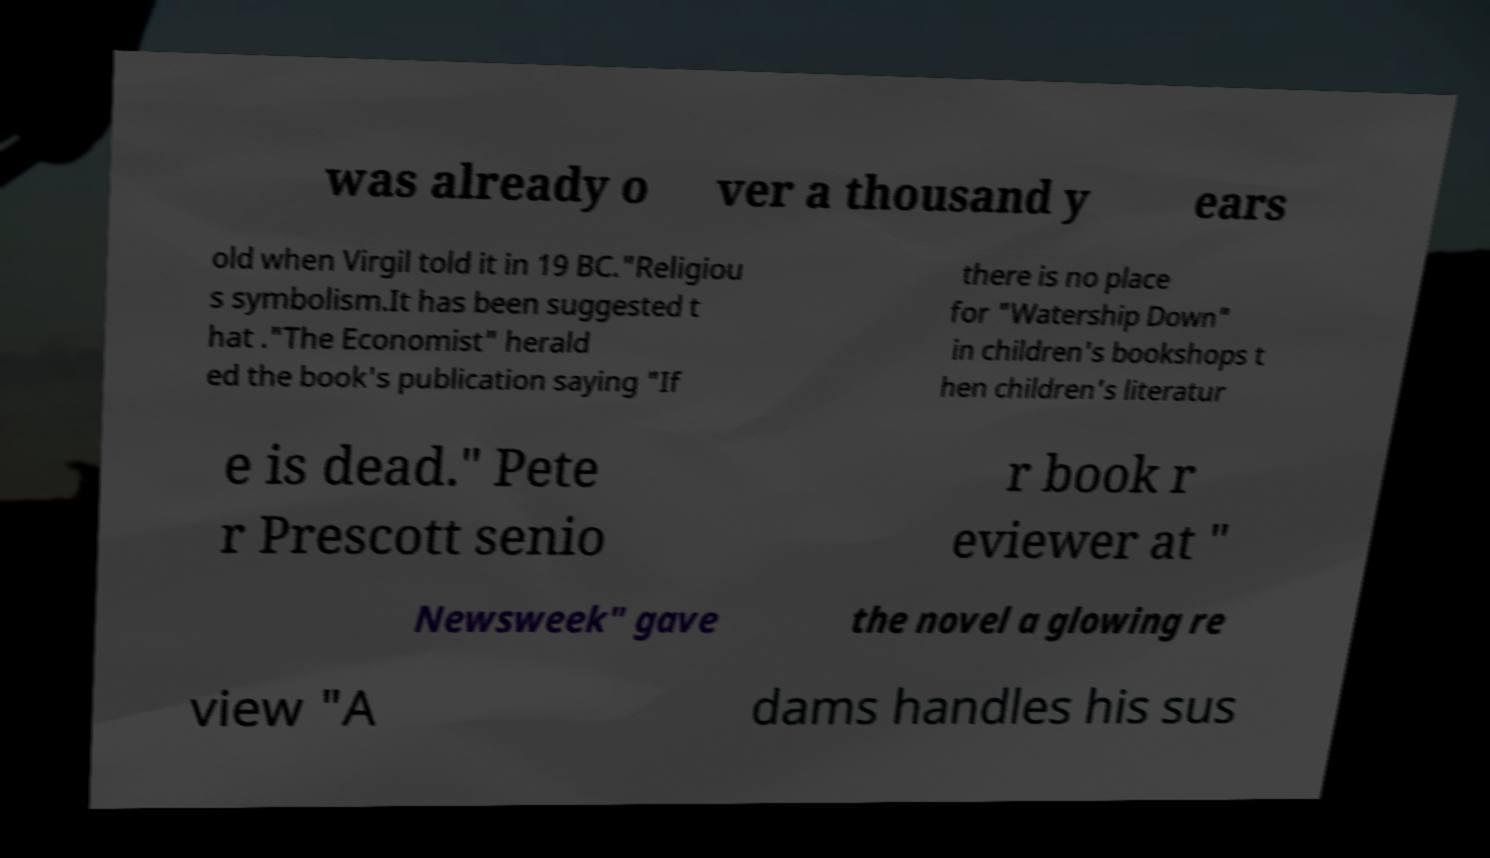Could you extract and type out the text from this image? was already o ver a thousand y ears old when Virgil told it in 19 BC."Religiou s symbolism.It has been suggested t hat ."The Economist" herald ed the book's publication saying "If there is no place for "Watership Down" in children's bookshops t hen children's literatur e is dead." Pete r Prescott senio r book r eviewer at " Newsweek" gave the novel a glowing re view "A dams handles his sus 